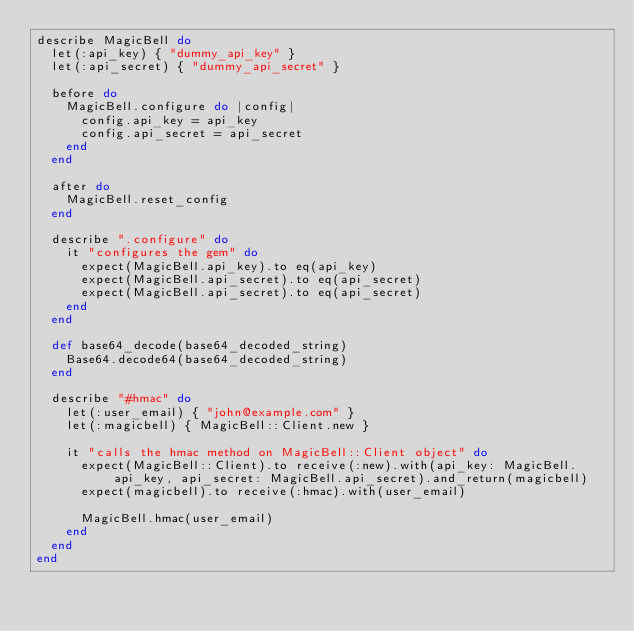Convert code to text. <code><loc_0><loc_0><loc_500><loc_500><_Ruby_>describe MagicBell do
  let(:api_key) { "dummy_api_key" }
  let(:api_secret) { "dummy_api_secret" }

  before do
    MagicBell.configure do |config|
      config.api_key = api_key
      config.api_secret = api_secret
    end
  end

  after do
    MagicBell.reset_config
  end

  describe ".configure" do
    it "configures the gem" do
      expect(MagicBell.api_key).to eq(api_key)
      expect(MagicBell.api_secret).to eq(api_secret)
      expect(MagicBell.api_secret).to eq(api_secret)
    end
  end

  def base64_decode(base64_decoded_string)
    Base64.decode64(base64_decoded_string)
  end

  describe "#hmac" do
    let(:user_email) { "john@example.com" }
    let(:magicbell) { MagicBell::Client.new }

    it "calls the hmac method on MagicBell::Client object" do
      expect(MagicBell::Client).to receive(:new).with(api_key: MagicBell.api_key, api_secret: MagicBell.api_secret).and_return(magicbell)
      expect(magicbell).to receive(:hmac).with(user_email)

      MagicBell.hmac(user_email)
    end
  end
end
</code> 